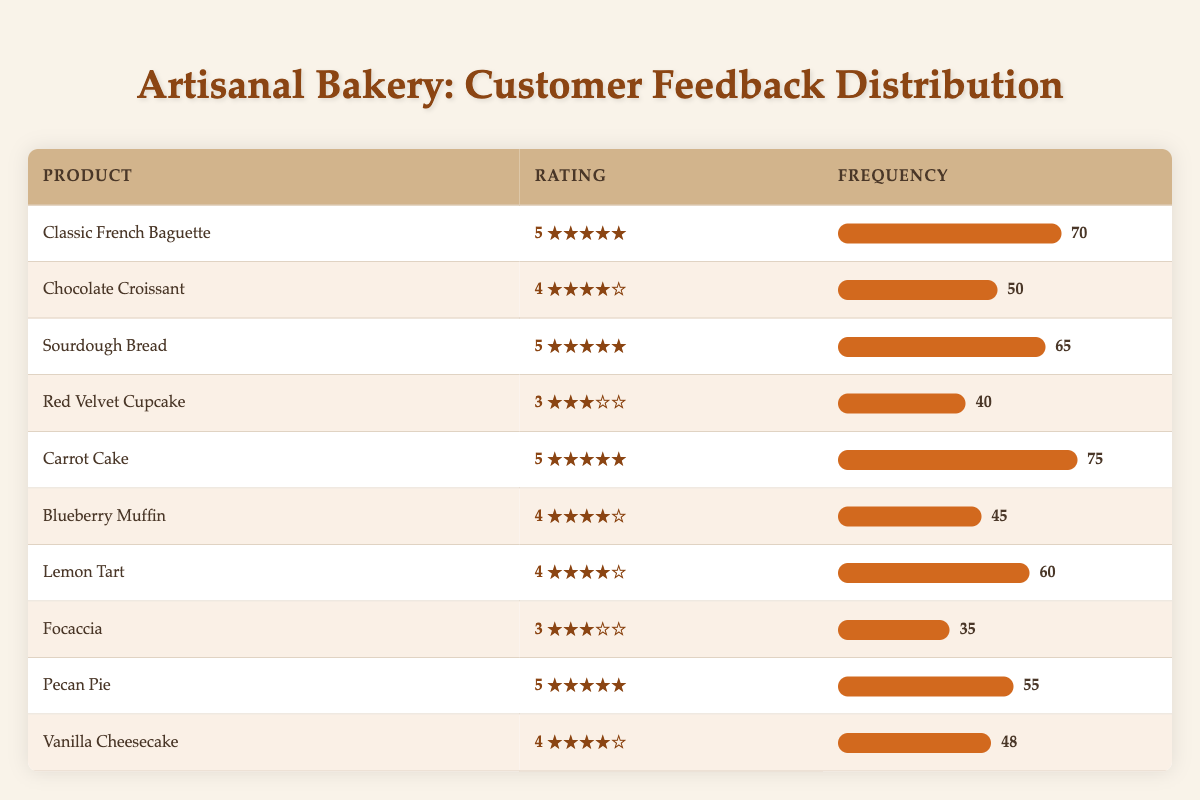What is the frequency of customer feedback ratings for the Classic French Baguette? The table shows that the frequency for the Classic French Baguette is 70.
Answer: 70 How many products received a rating of 5? The products with a rating of 5 are: Classic French Baguette, Sourdough Bread, Carrot Cake, and Pecan Pie. This totals to 4 products.
Answer: 4 What product received the lowest rating of 3, and what is its frequency? The Red Velvet Cupcake and Focaccia are the only products rated 3. The Focaccia has a frequency of 35, while Red Velvet Cupcake has a frequency of 40; hence Focaccia is the one with the lowest frequency.
Answer: Focaccia, frequency 35 What is the average frequency of all products rated 4? The products with a rating of 4 are the Chocolate Croissant, Blueberry Muffin, Lemon Tart, and Vanilla Cheesecake, with frequencies of 50, 45, 60, and 48 respectively. Summing these gives 50 + 45 + 60 + 48 = 203, and with 4 products, the average is 203/4 = 50.75.
Answer: 50.75 Is it true that the Carrot Cake has the highest frequency among all products? The Carrot Cake has a frequency of 75, which is higher than any other product's frequency listed in the table.
Answer: Yes Which product has the highest frequency of feedback ratings, and what is that frequency? The table indicates that the Carrot Cake has the highest frequency of 75.
Answer: Carrot Cake, frequency 75 How many total feedback responses were captured for products rated 5? The products rated 5 are Classic French Baguette (70), Sourdough Bread (65), Carrot Cake (75), and Pecan Pie (55). Summing these gives 70 + 65 + 75 + 55 = 265 total responses.
Answer: 265 What is the difference in frequency between the highest and lowest rated products? The highest frequency is from the Carrot Cake with 75, and the lowest frequency is from Focaccia with 35. The difference is 75 - 35 = 40.
Answer: 40 Which product has a frequency of 45, and what is its corresponding rating? The Blueberry Muffin has a frequency of 45 and a rating of 4.
Answer: Blueberry Muffin, rating 4 